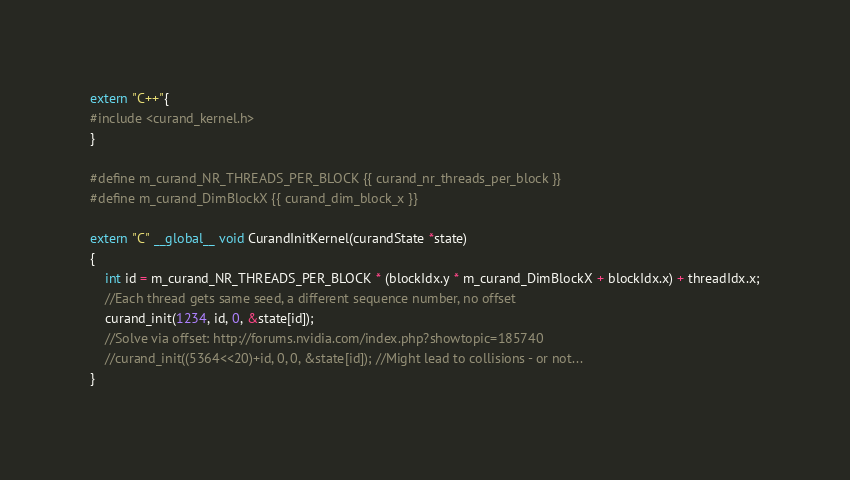<code> <loc_0><loc_0><loc_500><loc_500><_Cuda_>extern "C++"{
#include <curand_kernel.h>
}

#define m_curand_NR_THREADS_PER_BLOCK {{ curand_nr_threads_per_block }}
#define m_curand_DimBlockX {{ curand_dim_block_x }}

extern "C" __global__ void CurandInitKernel(curandState *state)
{
    int id = m_curand_NR_THREADS_PER_BLOCK * (blockIdx.y * m_curand_DimBlockX + blockIdx.x) + threadIdx.x;
    //Each thread gets same seed, a different sequence number, no offset 
    curand_init(1234, id, 0, &state[id]);
    //Solve via offset: http://forums.nvidia.com/index.php?showtopic=185740
    //curand_init((5364<<20)+id, 0, 0, &state[id]); //Might lead to collisions - or not...
}

</code> 